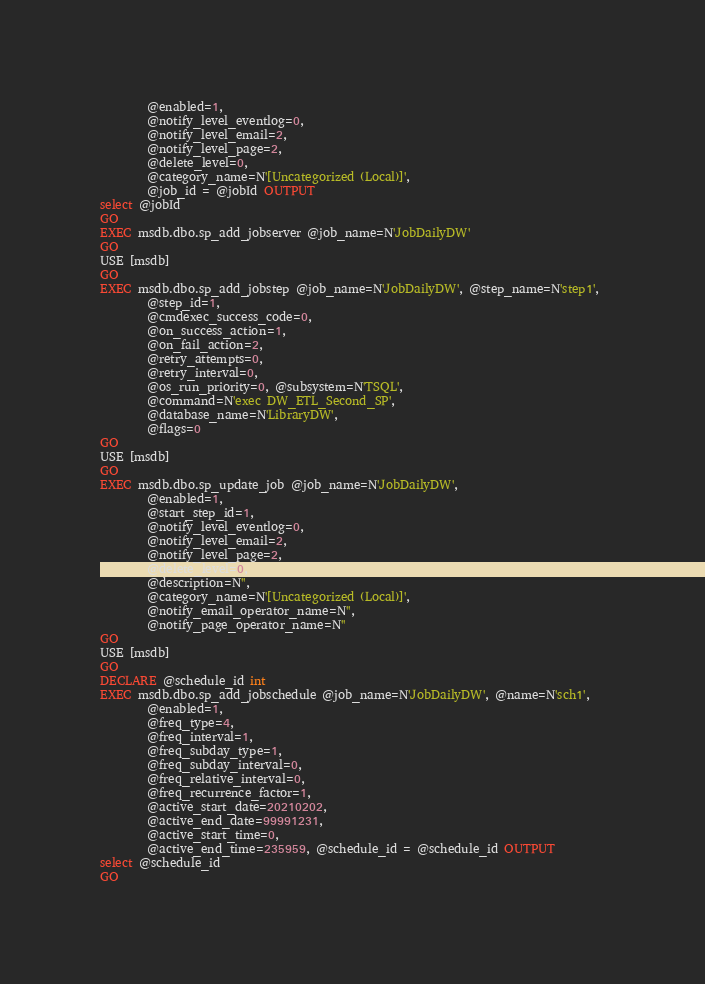Convert code to text. <code><loc_0><loc_0><loc_500><loc_500><_SQL_>		@enabled=1, 
		@notify_level_eventlog=0, 
		@notify_level_email=2, 
		@notify_level_page=2, 
		@delete_level=0, 
		@category_name=N'[Uncategorized (Local)]', 
		@job_id = @jobId OUTPUT
select @jobId
GO
EXEC msdb.dbo.sp_add_jobserver @job_name=N'JobDailyDW'
GO
USE [msdb]
GO
EXEC msdb.dbo.sp_add_jobstep @job_name=N'JobDailyDW', @step_name=N'step1', 
		@step_id=1, 
		@cmdexec_success_code=0, 
		@on_success_action=1, 
		@on_fail_action=2, 
		@retry_attempts=0, 
		@retry_interval=0, 
		@os_run_priority=0, @subsystem=N'TSQL', 
		@command=N'exec DW_ETL_Second_SP', 
		@database_name=N'LibraryDW', 
		@flags=0
GO
USE [msdb]
GO
EXEC msdb.dbo.sp_update_job @job_name=N'JobDailyDW', 
		@enabled=1, 
		@start_step_id=1, 
		@notify_level_eventlog=0, 
		@notify_level_email=2, 
		@notify_level_page=2, 
		@delete_level=0, 
		@description=N'', 
		@category_name=N'[Uncategorized (Local)]', 
		@notify_email_operator_name=N'', 
		@notify_page_operator_name=N''
GO
USE [msdb]
GO
DECLARE @schedule_id int
EXEC msdb.dbo.sp_add_jobschedule @job_name=N'JobDailyDW', @name=N'sch1', 
		@enabled=1, 
		@freq_type=4, 
		@freq_interval=1, 
		@freq_subday_type=1, 
		@freq_subday_interval=0, 
		@freq_relative_interval=0, 
		@freq_recurrence_factor=1, 
		@active_start_date=20210202, 
		@active_end_date=99991231, 
		@active_start_time=0, 
		@active_end_time=235959, @schedule_id = @schedule_id OUTPUT
select @schedule_id
GO
</code> 